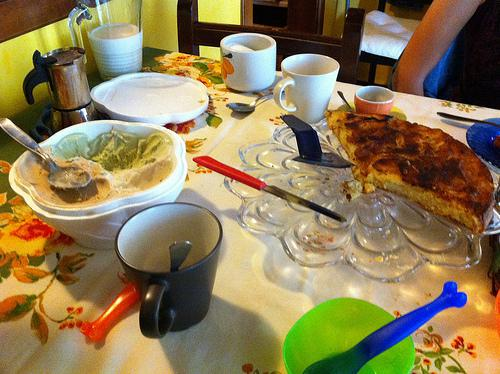Question: where is the blue spoon?
Choices:
A. In the green bowl.
B. In the sink.
C. In the crock pot.
D. In the dishwasher.
Answer with the letter. Answer: A Question: how much cake is left?
Choices:
A. Half.
B. Whole cake.
C. One slice.
D. None.
Answer with the letter. Answer: A Question: what is in the white bowl?
Choices:
A. Ice cream.
B. Mashed potatos.
C. Soup.
D. Peas.
Answer with the letter. Answer: A 